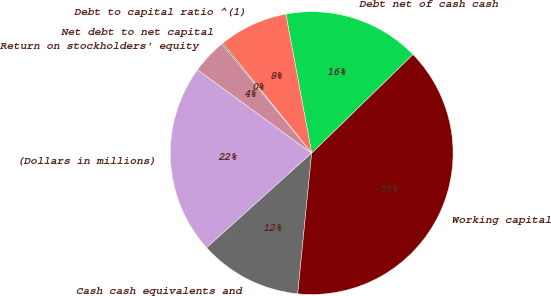<chart> <loc_0><loc_0><loc_500><loc_500><pie_chart><fcel>(Dollars in millions)<fcel>Cash cash equivalents and<fcel>Working capital<fcel>Debt net of cash cash<fcel>Debt to capital ratio ^(1)<fcel>Net debt to net capital<fcel>Return on stockholders' equity<nl><fcel>21.71%<fcel>11.76%<fcel>38.87%<fcel>15.63%<fcel>7.89%<fcel>0.14%<fcel>4.01%<nl></chart> 